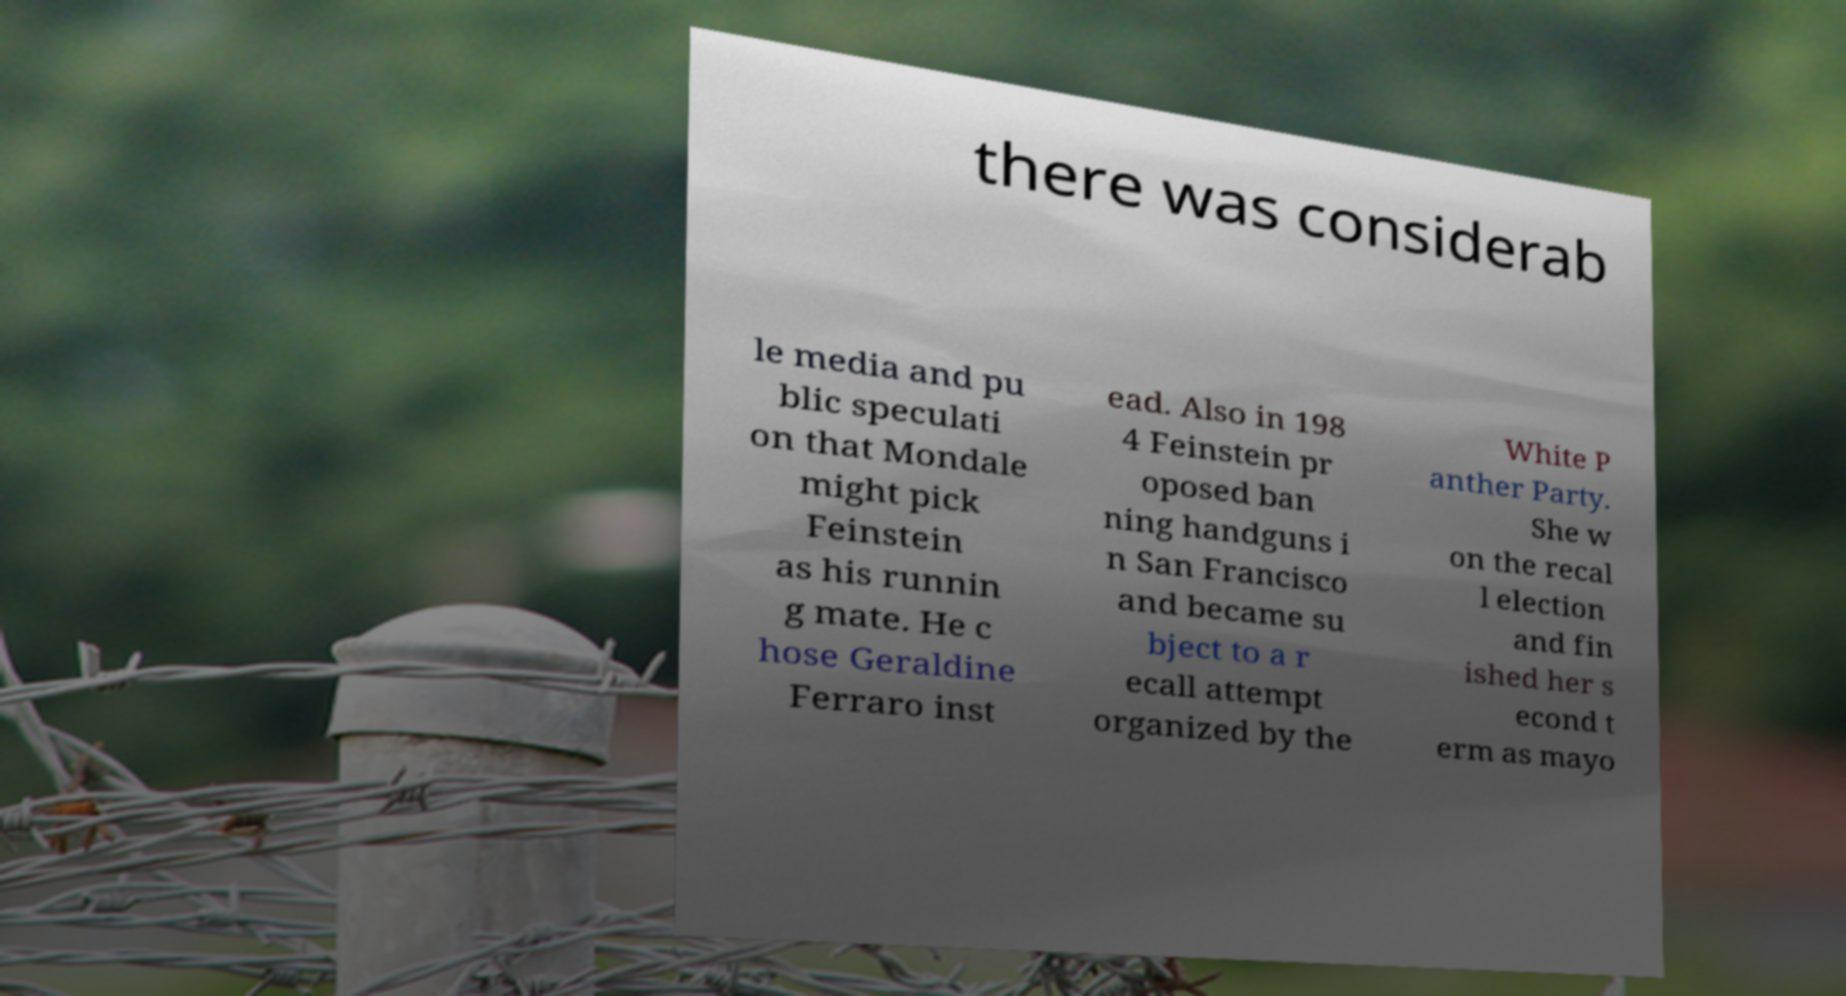For documentation purposes, I need the text within this image transcribed. Could you provide that? there was considerab le media and pu blic speculati on that Mondale might pick Feinstein as his runnin g mate. He c hose Geraldine Ferraro inst ead. Also in 198 4 Feinstein pr oposed ban ning handguns i n San Francisco and became su bject to a r ecall attempt organized by the White P anther Party. She w on the recal l election and fin ished her s econd t erm as mayo 